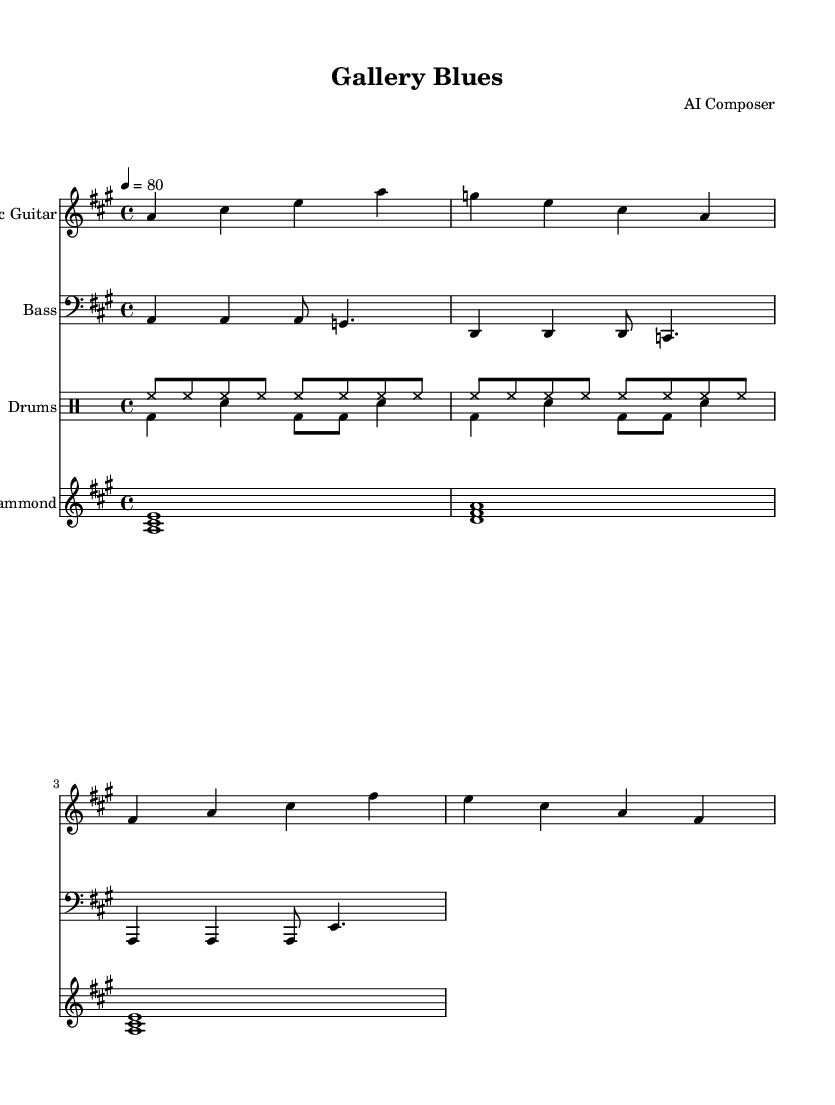What is the key signature of this music? The key signature is presented at the beginning of the sheet music, and it indicates two sharps, which correspond to A major.
Answer: A major What is the time signature of this music? The time signature is indicated at the beginning of the score and is shown as "4/4," meaning there are four beats in a measure and the quarter note gets one beat.
Answer: 4/4 What is the tempo marking for this piece? The tempo marking appears at the beginning of the score with "4 = 80," meaning there are 80 beats per minute.
Answer: 80 How many measures are there in the electric guitar part? By counting the groups of notes in the electric guitar staff, we see there are four measures total.
Answer: Four What type of ensemble is this composition scored for? The score consists of multiple instrumental voices: electric guitar, bass, drums, and Hammond organ. This signifies it's for a small band.
Answer: Small band Which instrument plays the lowest range in this ensemble? The bass guitar is depicted in the bass clef and its notes are lower than the other staves, indicating it plays the lowest range in the ensemble.
Answer: Bass guitar How many different drum voices are present in the drum part? The drum part is divided into two separate voices: one for hi-hat and one for bass drum and snare. This indicates there are two distinct drum voices.
Answer: Two 